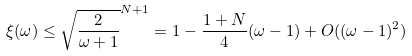<formula> <loc_0><loc_0><loc_500><loc_500>\xi ( \omega ) \leq \sqrt { \frac { 2 } { \omega + 1 } } ^ { N + 1 } = 1 - \frac { 1 + N } { 4 } ( \omega - 1 ) + O ( ( \omega - 1 ) ^ { 2 } )</formula> 